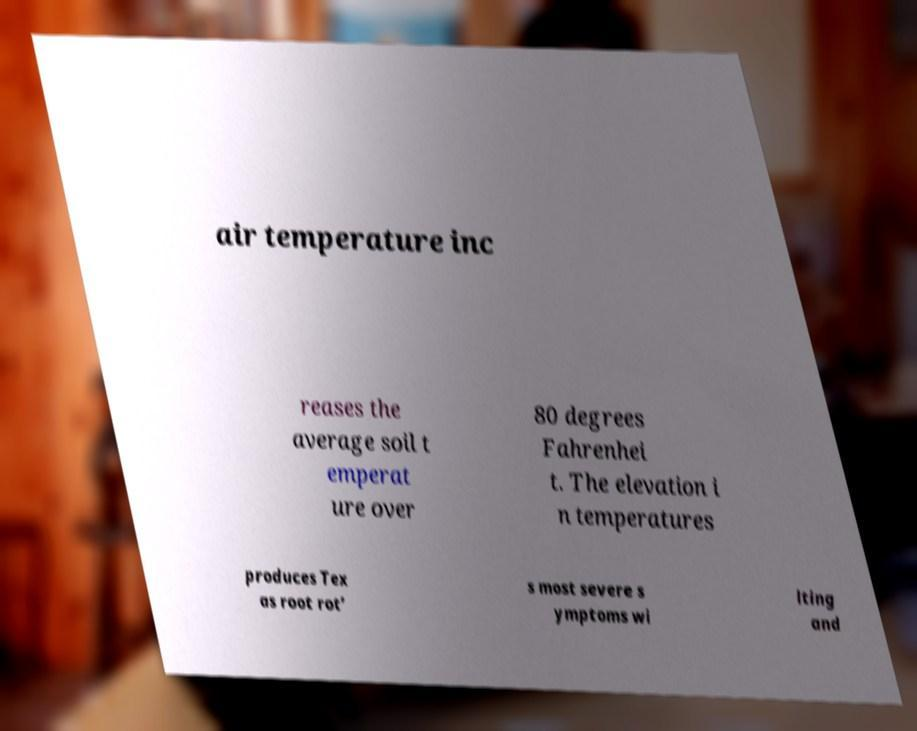For documentation purposes, I need the text within this image transcribed. Could you provide that? air temperature inc reases the average soil t emperat ure over 80 degrees Fahrenhei t. The elevation i n temperatures produces Tex as root rot’ s most severe s ymptoms wi lting and 